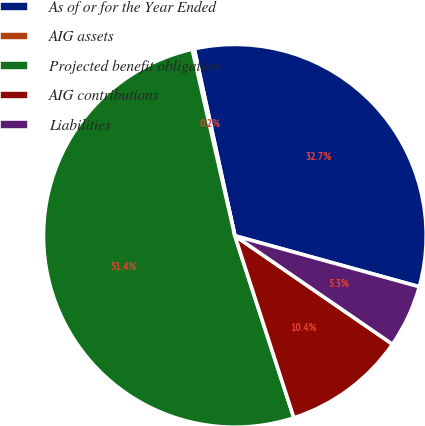Convert chart to OTSL. <chart><loc_0><loc_0><loc_500><loc_500><pie_chart><fcel>As of or for the Year Ended<fcel>AIG assets<fcel>Projected benefit obligation<fcel>AIG contributions<fcel>Liabilities<nl><fcel>32.69%<fcel>0.18%<fcel>51.4%<fcel>10.42%<fcel>5.3%<nl></chart> 